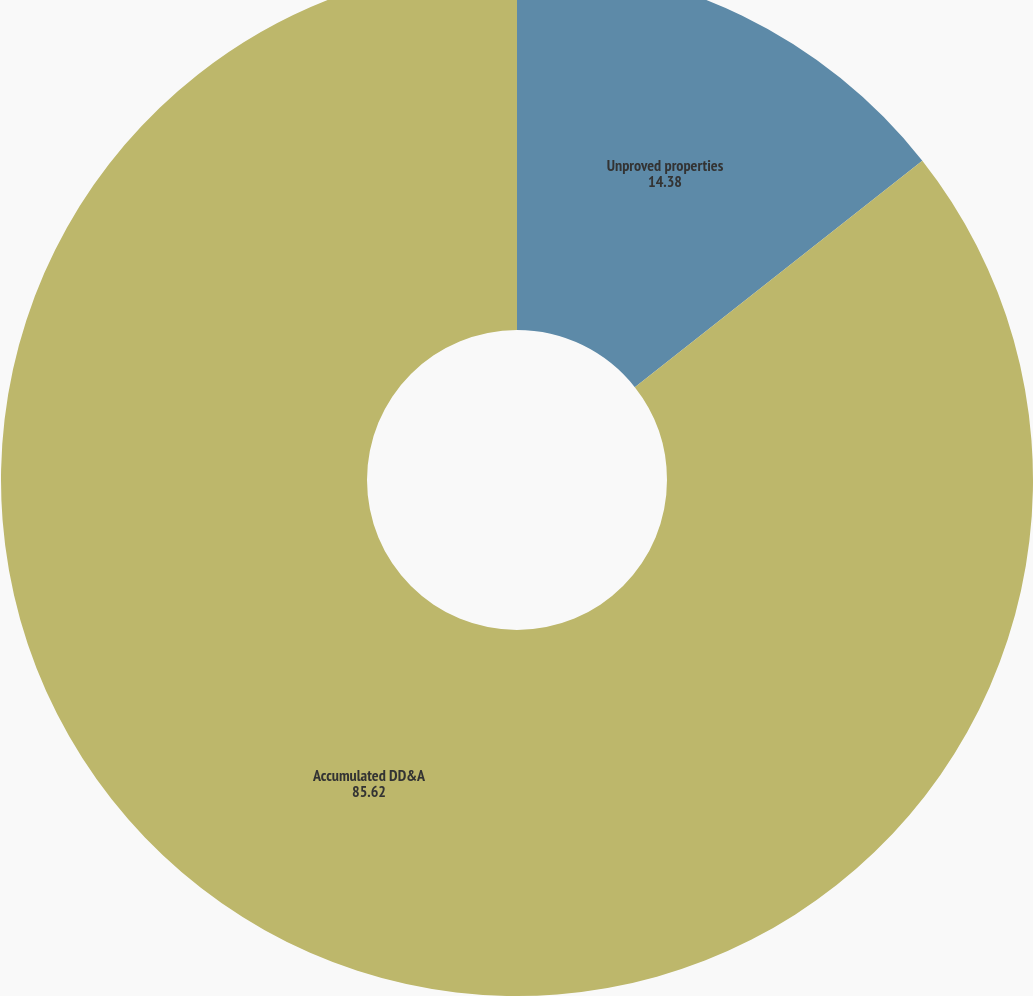<chart> <loc_0><loc_0><loc_500><loc_500><pie_chart><fcel>Unproved properties<fcel>Accumulated DD&A<nl><fcel>14.38%<fcel>85.62%<nl></chart> 